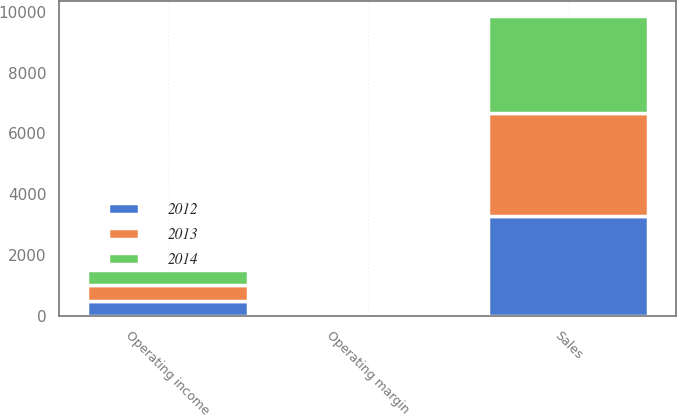<chart> <loc_0><loc_0><loc_500><loc_500><stacked_bar_chart><ecel><fcel>Sales<fcel>Operating income<fcel>Operating margin<nl><fcel>2012<fcel>3288.9<fcel>484.9<fcel>14.7<nl><fcel>2013<fcel>3387.3<fcel>515.9<fcel>15.2<nl><fcel>2014<fcel>3206.7<fcel>512<fcel>16<nl></chart> 